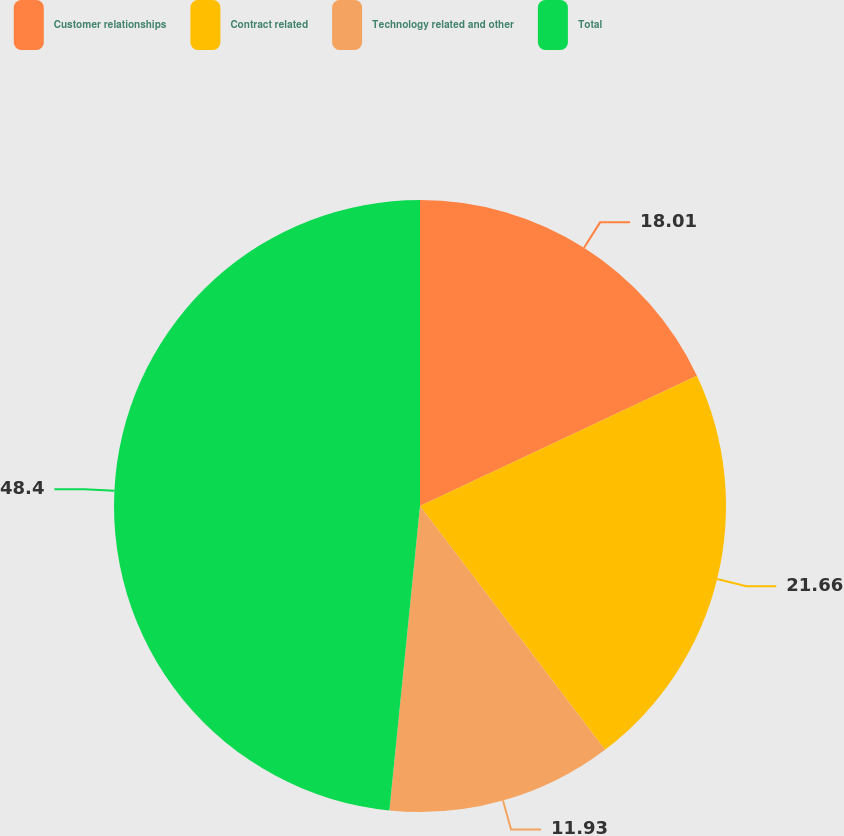<chart> <loc_0><loc_0><loc_500><loc_500><pie_chart><fcel>Customer relationships<fcel>Contract related<fcel>Technology related and other<fcel>Total<nl><fcel>18.01%<fcel>21.66%<fcel>11.93%<fcel>48.41%<nl></chart> 